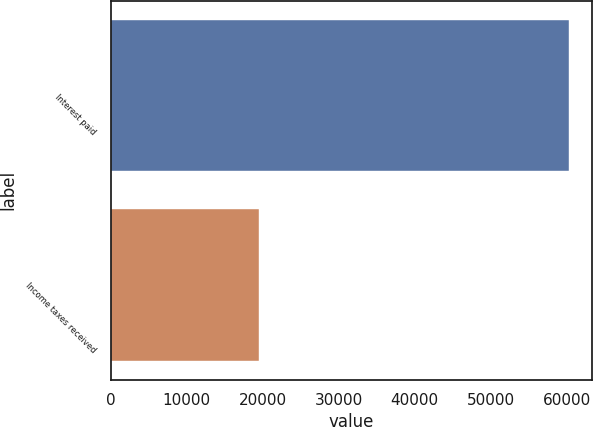Convert chart to OTSL. <chart><loc_0><loc_0><loc_500><loc_500><bar_chart><fcel>Interest paid<fcel>Income taxes received<nl><fcel>60380<fcel>19513<nl></chart> 